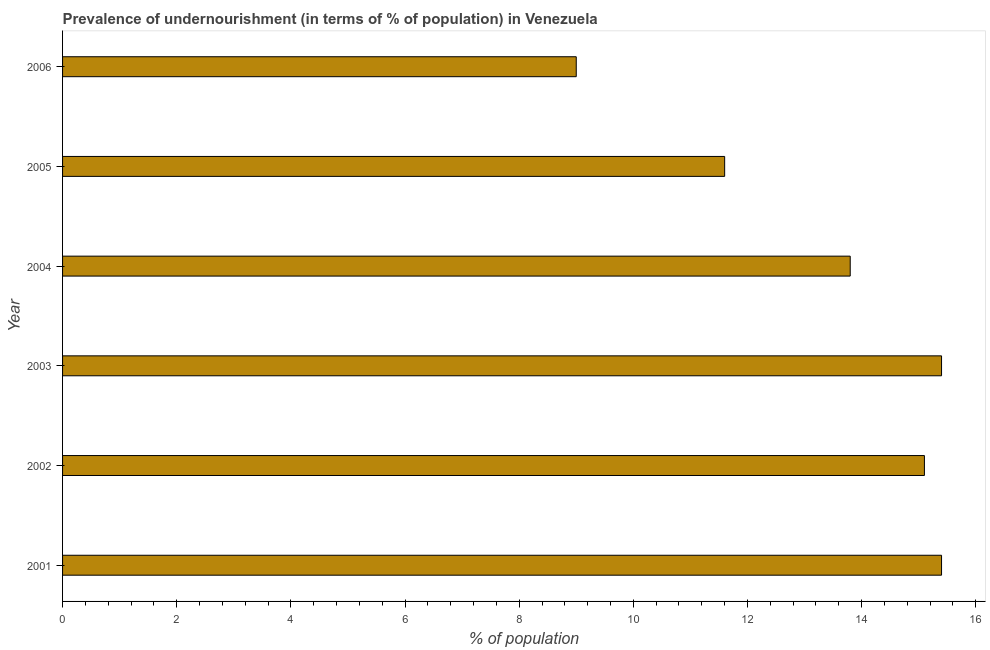Does the graph contain any zero values?
Ensure brevity in your answer.  No. Does the graph contain grids?
Your answer should be compact. No. What is the title of the graph?
Your response must be concise. Prevalence of undernourishment (in terms of % of population) in Venezuela. What is the label or title of the X-axis?
Offer a very short reply. % of population. Across all years, what is the maximum percentage of undernourished population?
Your response must be concise. 15.4. In which year was the percentage of undernourished population minimum?
Provide a short and direct response. 2006. What is the sum of the percentage of undernourished population?
Offer a very short reply. 80.3. What is the difference between the percentage of undernourished population in 2001 and 2005?
Offer a terse response. 3.8. What is the average percentage of undernourished population per year?
Your answer should be compact. 13.38. What is the median percentage of undernourished population?
Your answer should be compact. 14.45. In how many years, is the percentage of undernourished population greater than 7.6 %?
Your answer should be very brief. 6. Do a majority of the years between 2002 and 2005 (inclusive) have percentage of undernourished population greater than 5.6 %?
Ensure brevity in your answer.  Yes. What is the ratio of the percentage of undernourished population in 2002 to that in 2004?
Your answer should be very brief. 1.09. Is the percentage of undernourished population in 2005 less than that in 2006?
Make the answer very short. No. Is the difference between the percentage of undernourished population in 2001 and 2002 greater than the difference between any two years?
Give a very brief answer. No. What is the difference between the highest and the second highest percentage of undernourished population?
Your answer should be compact. 0. Is the sum of the percentage of undernourished population in 2001 and 2005 greater than the maximum percentage of undernourished population across all years?
Make the answer very short. Yes. How many bars are there?
Offer a terse response. 6. Are all the bars in the graph horizontal?
Keep it short and to the point. Yes. Are the values on the major ticks of X-axis written in scientific E-notation?
Keep it short and to the point. No. What is the % of population of 2002?
Give a very brief answer. 15.1. What is the % of population in 2004?
Provide a succinct answer. 13.8. What is the difference between the % of population in 2001 and 2003?
Provide a succinct answer. 0. What is the difference between the % of population in 2001 and 2005?
Your answer should be compact. 3.8. What is the difference between the % of population in 2001 and 2006?
Your response must be concise. 6.4. What is the difference between the % of population in 2002 and 2003?
Give a very brief answer. -0.3. What is the difference between the % of population in 2002 and 2005?
Your answer should be compact. 3.5. What is the difference between the % of population in 2002 and 2006?
Ensure brevity in your answer.  6.1. What is the difference between the % of population in 2003 and 2005?
Give a very brief answer. 3.8. What is the difference between the % of population in 2003 and 2006?
Offer a terse response. 6.4. What is the difference between the % of population in 2004 and 2006?
Offer a terse response. 4.8. What is the difference between the % of population in 2005 and 2006?
Offer a terse response. 2.6. What is the ratio of the % of population in 2001 to that in 2002?
Your response must be concise. 1.02. What is the ratio of the % of population in 2001 to that in 2004?
Your answer should be compact. 1.12. What is the ratio of the % of population in 2001 to that in 2005?
Your response must be concise. 1.33. What is the ratio of the % of population in 2001 to that in 2006?
Offer a very short reply. 1.71. What is the ratio of the % of population in 2002 to that in 2003?
Your answer should be very brief. 0.98. What is the ratio of the % of population in 2002 to that in 2004?
Give a very brief answer. 1.09. What is the ratio of the % of population in 2002 to that in 2005?
Ensure brevity in your answer.  1.3. What is the ratio of the % of population in 2002 to that in 2006?
Offer a very short reply. 1.68. What is the ratio of the % of population in 2003 to that in 2004?
Your response must be concise. 1.12. What is the ratio of the % of population in 2003 to that in 2005?
Your answer should be compact. 1.33. What is the ratio of the % of population in 2003 to that in 2006?
Your answer should be very brief. 1.71. What is the ratio of the % of population in 2004 to that in 2005?
Ensure brevity in your answer.  1.19. What is the ratio of the % of population in 2004 to that in 2006?
Your response must be concise. 1.53. What is the ratio of the % of population in 2005 to that in 2006?
Your response must be concise. 1.29. 